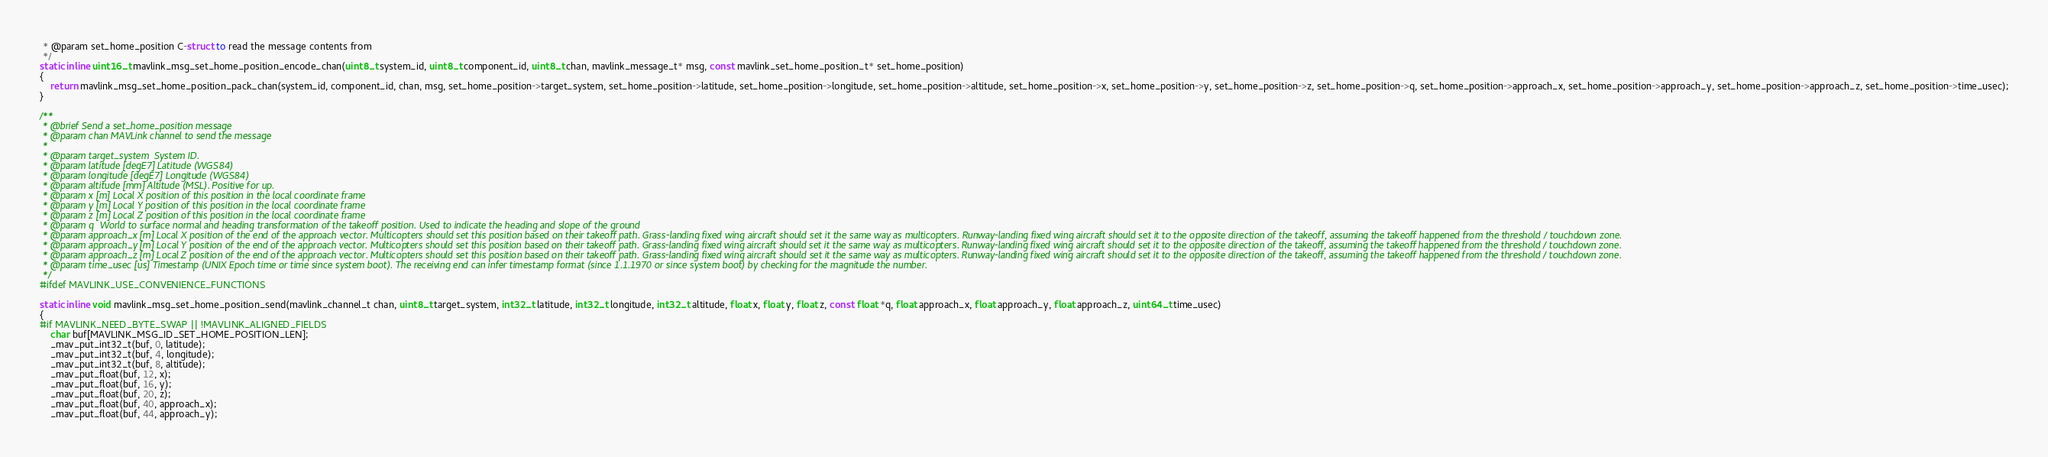Convert code to text. <code><loc_0><loc_0><loc_500><loc_500><_C_> * @param set_home_position C-struct to read the message contents from
 */
static inline uint16_t mavlink_msg_set_home_position_encode_chan(uint8_t system_id, uint8_t component_id, uint8_t chan, mavlink_message_t* msg, const mavlink_set_home_position_t* set_home_position)
{
    return mavlink_msg_set_home_position_pack_chan(system_id, component_id, chan, msg, set_home_position->target_system, set_home_position->latitude, set_home_position->longitude, set_home_position->altitude, set_home_position->x, set_home_position->y, set_home_position->z, set_home_position->q, set_home_position->approach_x, set_home_position->approach_y, set_home_position->approach_z, set_home_position->time_usec);
}

/**
 * @brief Send a set_home_position message
 * @param chan MAVLink channel to send the message
 *
 * @param target_system  System ID.
 * @param latitude [degE7] Latitude (WGS84)
 * @param longitude [degE7] Longitude (WGS84)
 * @param altitude [mm] Altitude (MSL). Positive for up.
 * @param x [m] Local X position of this position in the local coordinate frame
 * @param y [m] Local Y position of this position in the local coordinate frame
 * @param z [m] Local Z position of this position in the local coordinate frame
 * @param q  World to surface normal and heading transformation of the takeoff position. Used to indicate the heading and slope of the ground
 * @param approach_x [m] Local X position of the end of the approach vector. Multicopters should set this position based on their takeoff path. Grass-landing fixed wing aircraft should set it the same way as multicopters. Runway-landing fixed wing aircraft should set it to the opposite direction of the takeoff, assuming the takeoff happened from the threshold / touchdown zone.
 * @param approach_y [m] Local Y position of the end of the approach vector. Multicopters should set this position based on their takeoff path. Grass-landing fixed wing aircraft should set it the same way as multicopters. Runway-landing fixed wing aircraft should set it to the opposite direction of the takeoff, assuming the takeoff happened from the threshold / touchdown zone.
 * @param approach_z [m] Local Z position of the end of the approach vector. Multicopters should set this position based on their takeoff path. Grass-landing fixed wing aircraft should set it the same way as multicopters. Runway-landing fixed wing aircraft should set it to the opposite direction of the takeoff, assuming the takeoff happened from the threshold / touchdown zone.
 * @param time_usec [us] Timestamp (UNIX Epoch time or time since system boot). The receiving end can infer timestamp format (since 1.1.1970 or since system boot) by checking for the magnitude the number.
 */
#ifdef MAVLINK_USE_CONVENIENCE_FUNCTIONS

static inline void mavlink_msg_set_home_position_send(mavlink_channel_t chan, uint8_t target_system, int32_t latitude, int32_t longitude, int32_t altitude, float x, float y, float z, const float *q, float approach_x, float approach_y, float approach_z, uint64_t time_usec)
{
#if MAVLINK_NEED_BYTE_SWAP || !MAVLINK_ALIGNED_FIELDS
    char buf[MAVLINK_MSG_ID_SET_HOME_POSITION_LEN];
    _mav_put_int32_t(buf, 0, latitude);
    _mav_put_int32_t(buf, 4, longitude);
    _mav_put_int32_t(buf, 8, altitude);
    _mav_put_float(buf, 12, x);
    _mav_put_float(buf, 16, y);
    _mav_put_float(buf, 20, z);
    _mav_put_float(buf, 40, approach_x);
    _mav_put_float(buf, 44, approach_y);</code> 